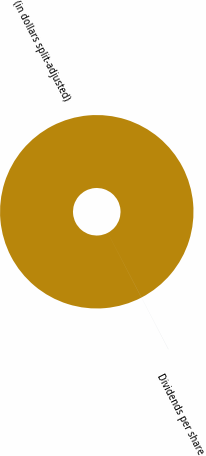Convert chart to OTSL. <chart><loc_0><loc_0><loc_500><loc_500><pie_chart><fcel>(in dollars split-adjusted)<fcel>Dividends per share<nl><fcel>99.99%<fcel>0.01%<nl></chart> 